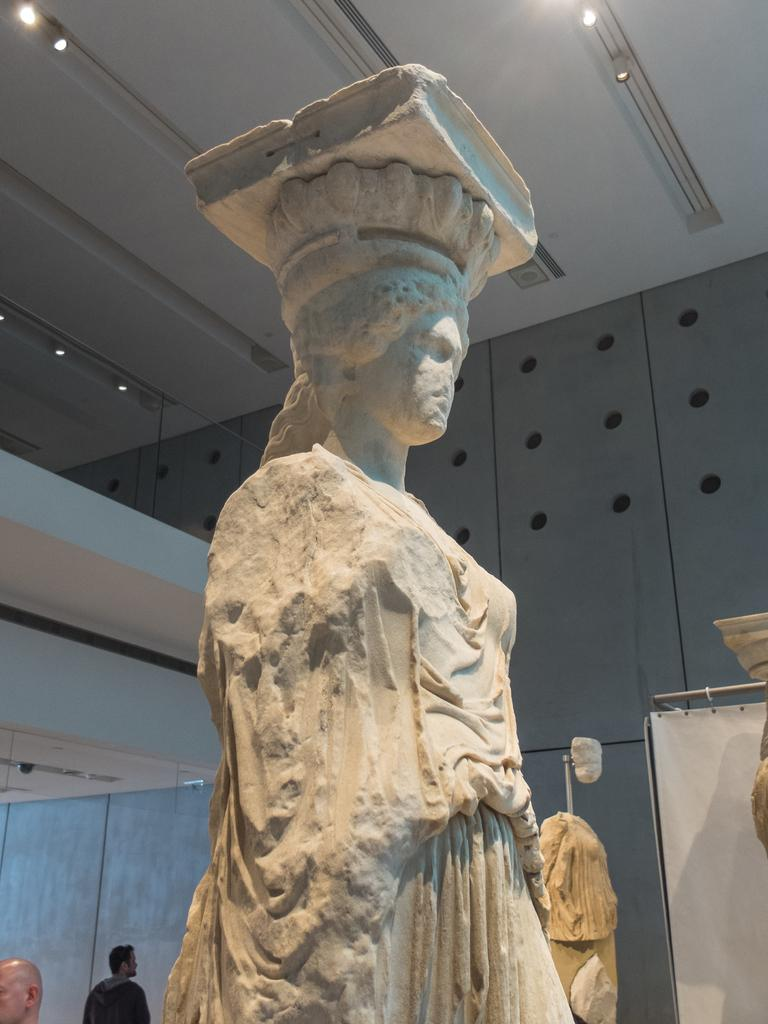What type of structure can be seen in the image? There is a wall in the image. What is located near the wall? There is a statue in the image. How many people are visible in the image? There are two persons standing on the left side of the image. What can be seen at the top of the image? There are lights at the top of the image. What color is the cloth on the right side of the image? There is a white color cloth on the right side of the image. What type of advice can be seen written on the statue in the image? There is no advice written on the statue in the image; it is a statue and not a source of advice. Can you see any boots in the image? There are no boots present in the image. 